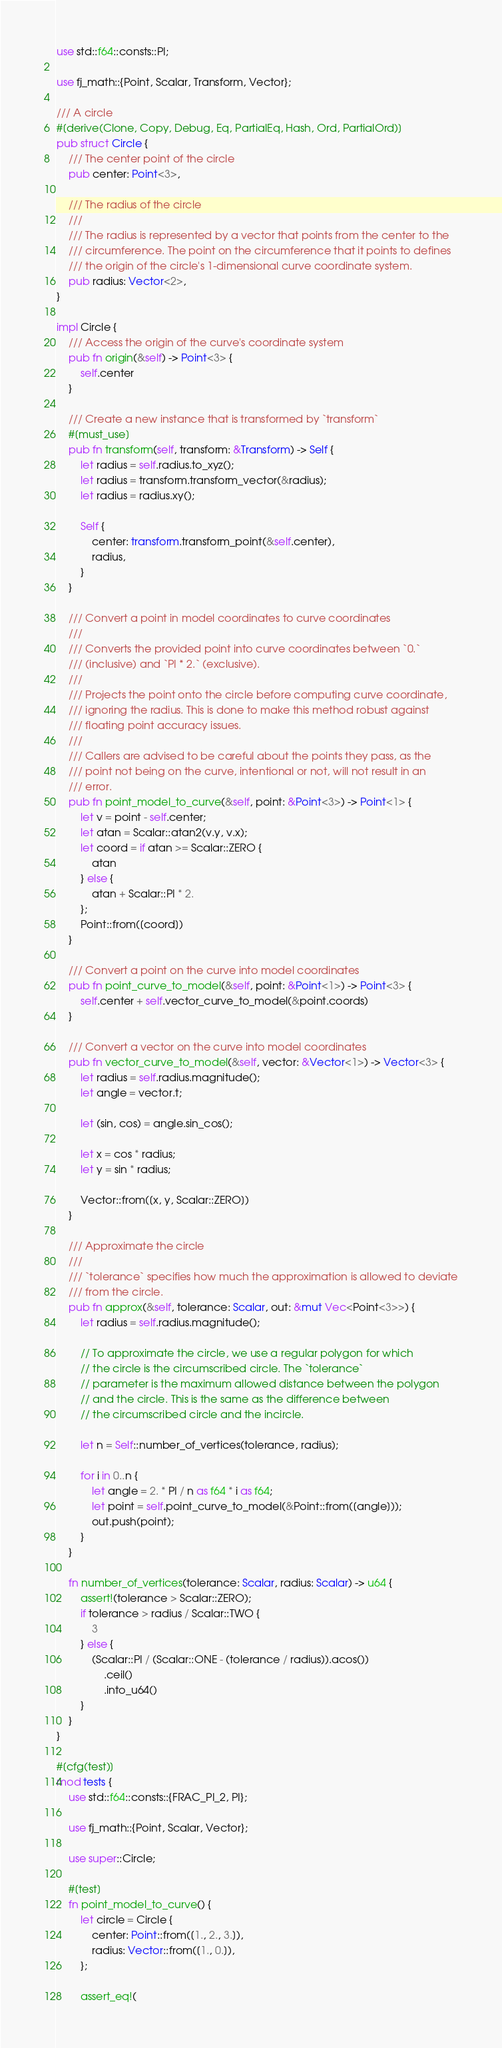Convert code to text. <code><loc_0><loc_0><loc_500><loc_500><_Rust_>use std::f64::consts::PI;

use fj_math::{Point, Scalar, Transform, Vector};

/// A circle
#[derive(Clone, Copy, Debug, Eq, PartialEq, Hash, Ord, PartialOrd)]
pub struct Circle {
    /// The center point of the circle
    pub center: Point<3>,

    /// The radius of the circle
    ///
    /// The radius is represented by a vector that points from the center to the
    /// circumference. The point on the circumference that it points to defines
    /// the origin of the circle's 1-dimensional curve coordinate system.
    pub radius: Vector<2>,
}

impl Circle {
    /// Access the origin of the curve's coordinate system
    pub fn origin(&self) -> Point<3> {
        self.center
    }

    /// Create a new instance that is transformed by `transform`
    #[must_use]
    pub fn transform(self, transform: &Transform) -> Self {
        let radius = self.radius.to_xyz();
        let radius = transform.transform_vector(&radius);
        let radius = radius.xy();

        Self {
            center: transform.transform_point(&self.center),
            radius,
        }
    }

    /// Convert a point in model coordinates to curve coordinates
    ///
    /// Converts the provided point into curve coordinates between `0.`
    /// (inclusive) and `PI * 2.` (exclusive).
    ///
    /// Projects the point onto the circle before computing curve coordinate,
    /// ignoring the radius. This is done to make this method robust against
    /// floating point accuracy issues.
    ///
    /// Callers are advised to be careful about the points they pass, as the
    /// point not being on the curve, intentional or not, will not result in an
    /// error.
    pub fn point_model_to_curve(&self, point: &Point<3>) -> Point<1> {
        let v = point - self.center;
        let atan = Scalar::atan2(v.y, v.x);
        let coord = if atan >= Scalar::ZERO {
            atan
        } else {
            atan + Scalar::PI * 2.
        };
        Point::from([coord])
    }

    /// Convert a point on the curve into model coordinates
    pub fn point_curve_to_model(&self, point: &Point<1>) -> Point<3> {
        self.center + self.vector_curve_to_model(&point.coords)
    }

    /// Convert a vector on the curve into model coordinates
    pub fn vector_curve_to_model(&self, vector: &Vector<1>) -> Vector<3> {
        let radius = self.radius.magnitude();
        let angle = vector.t;

        let (sin, cos) = angle.sin_cos();

        let x = cos * radius;
        let y = sin * radius;

        Vector::from([x, y, Scalar::ZERO])
    }

    /// Approximate the circle
    ///
    /// `tolerance` specifies how much the approximation is allowed to deviate
    /// from the circle.
    pub fn approx(&self, tolerance: Scalar, out: &mut Vec<Point<3>>) {
        let radius = self.radius.magnitude();

        // To approximate the circle, we use a regular polygon for which
        // the circle is the circumscribed circle. The `tolerance`
        // parameter is the maximum allowed distance between the polygon
        // and the circle. This is the same as the difference between
        // the circumscribed circle and the incircle.

        let n = Self::number_of_vertices(tolerance, radius);

        for i in 0..n {
            let angle = 2. * PI / n as f64 * i as f64;
            let point = self.point_curve_to_model(&Point::from([angle]));
            out.push(point);
        }
    }

    fn number_of_vertices(tolerance: Scalar, radius: Scalar) -> u64 {
        assert!(tolerance > Scalar::ZERO);
        if tolerance > radius / Scalar::TWO {
            3
        } else {
            (Scalar::PI / (Scalar::ONE - (tolerance / radius)).acos())
                .ceil()
                .into_u64()
        }
    }
}

#[cfg(test)]
mod tests {
    use std::f64::consts::{FRAC_PI_2, PI};

    use fj_math::{Point, Scalar, Vector};

    use super::Circle;

    #[test]
    fn point_model_to_curve() {
        let circle = Circle {
            center: Point::from([1., 2., 3.]),
            radius: Vector::from([1., 0.]),
        };

        assert_eq!(</code> 